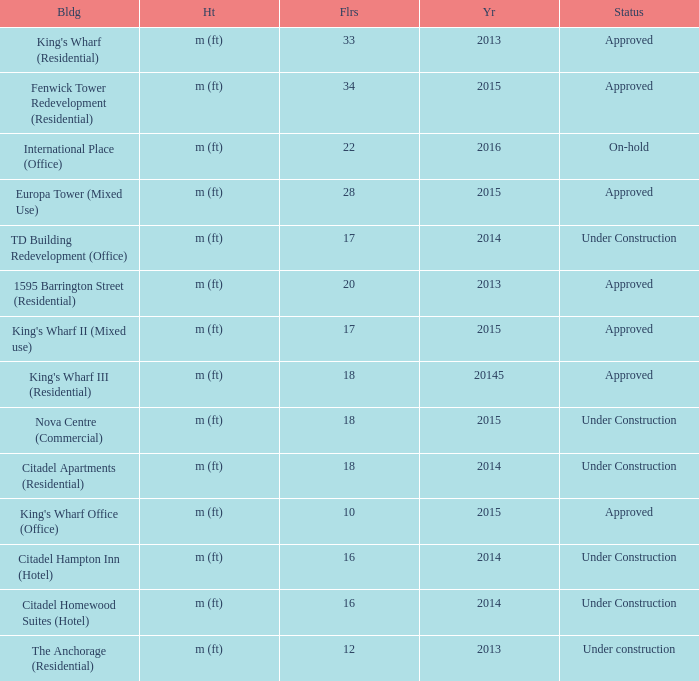What is the status of the building with less than 18 floors and later than 2013? Under Construction, Approved, Approved, Under Construction, Under Construction. 